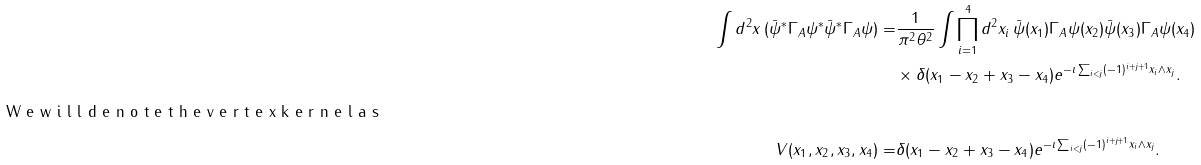Convert formula to latex. <formula><loc_0><loc_0><loc_500><loc_500>\int d ^ { 2 } x \, ( { \bar { \psi } } ^ { * } \Gamma _ { A } \psi ^ { * } { \bar { \psi } } ^ { * } \Gamma _ { A } \psi ) = & \frac { 1 } { \pi ^ { 2 } \theta ^ { 2 } } \int \prod _ { i = 1 } ^ { 4 } d ^ { 2 } x _ { i } \, { \bar { \psi } } ( x _ { 1 } ) \Gamma _ { A } \psi ( x _ { 2 } ) { \bar { \psi } } ( x _ { 3 } ) \Gamma _ { A } \psi ( x _ { 4 } ) \\ & \times \delta ( x _ { 1 } - x _ { 2 } + x _ { 3 } - x _ { 4 } ) e ^ { - \imath \sum _ { i < j } ( - 1 ) ^ { i + j + 1 } x _ { i } \wedge x _ { j } } . \intertext { W e w i l l d e n o t e t h e v e r t e x k e r n e l a s } V ( x _ { 1 } , x _ { 2 } , x _ { 3 } , x _ { 4 } ) = & \delta ( x _ { 1 } - x _ { 2 } + x _ { 3 } - x _ { 4 } ) e ^ { - \imath \sum _ { i < j } ( - 1 ) ^ { i + j + 1 } x _ { i } \wedge x _ { j } } .</formula> 